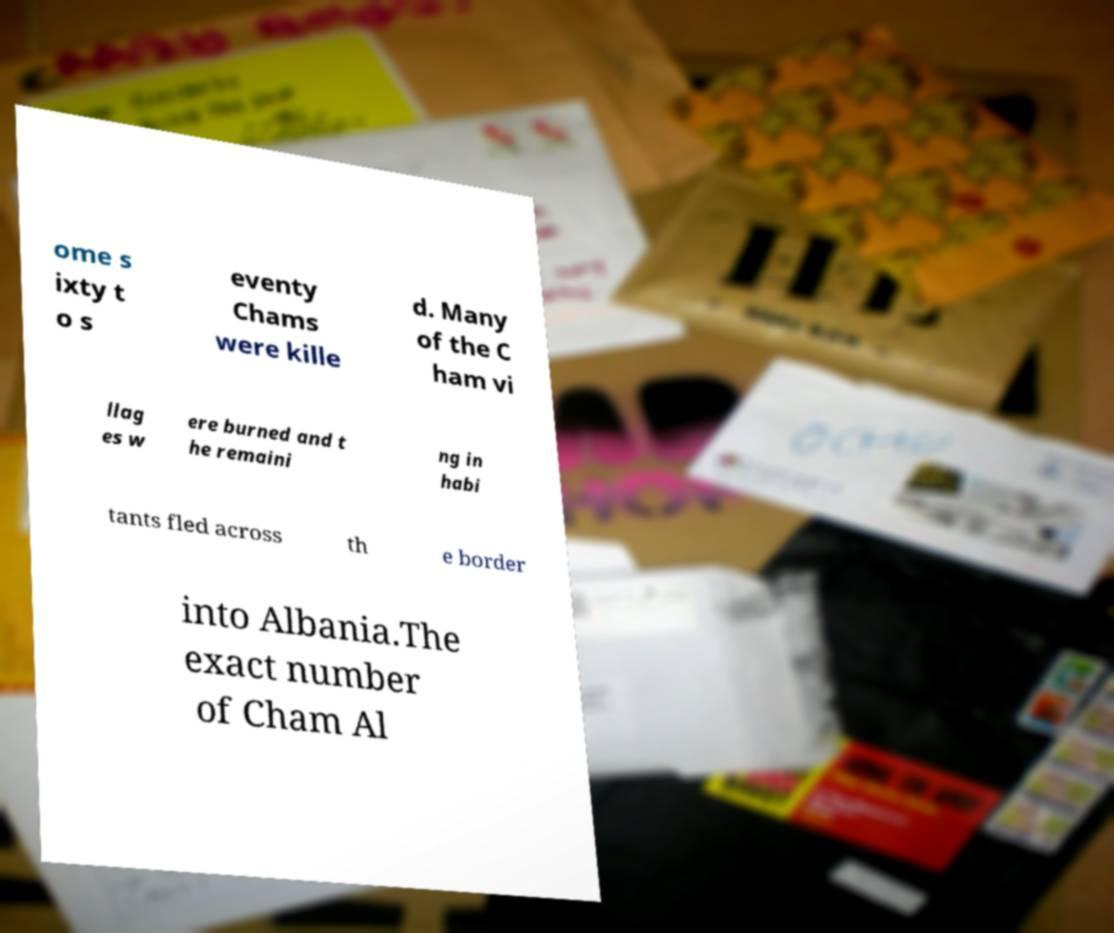Please read and relay the text visible in this image. What does it say? ome s ixty t o s eventy Chams were kille d. Many of the C ham vi llag es w ere burned and t he remaini ng in habi tants fled across th e border into Albania.The exact number of Cham Al 